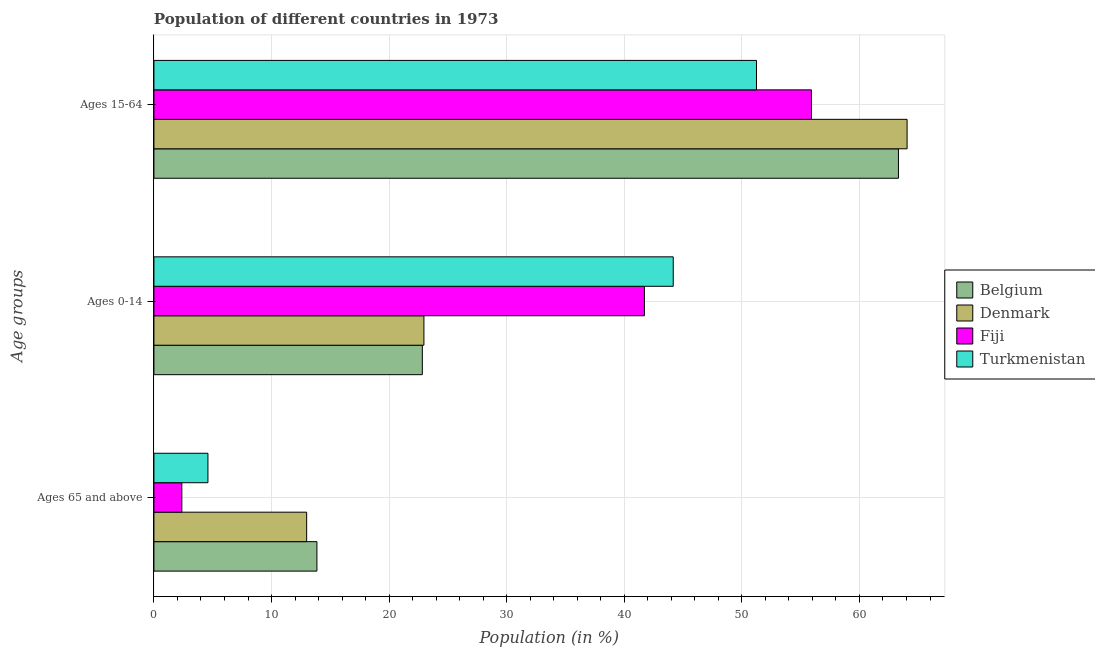How many bars are there on the 3rd tick from the top?
Offer a terse response. 4. How many bars are there on the 2nd tick from the bottom?
Offer a very short reply. 4. What is the label of the 3rd group of bars from the top?
Make the answer very short. Ages 65 and above. What is the percentage of population within the age-group of 65 and above in Fiji?
Your response must be concise. 2.37. Across all countries, what is the maximum percentage of population within the age-group of 65 and above?
Your answer should be very brief. 13.86. Across all countries, what is the minimum percentage of population within the age-group 0-14?
Ensure brevity in your answer.  22.82. In which country was the percentage of population within the age-group 0-14 maximum?
Provide a succinct answer. Turkmenistan. What is the total percentage of population within the age-group 15-64 in the graph?
Your answer should be compact. 234.52. What is the difference between the percentage of population within the age-group of 65 and above in Turkmenistan and that in Fiji?
Your answer should be compact. 2.22. What is the difference between the percentage of population within the age-group of 65 and above in Turkmenistan and the percentage of population within the age-group 0-14 in Denmark?
Provide a succinct answer. -18.37. What is the average percentage of population within the age-group 0-14 per country?
Offer a terse response. 32.91. What is the difference between the percentage of population within the age-group 0-14 and percentage of population within the age-group 15-64 in Belgium?
Offer a very short reply. -40.49. In how many countries, is the percentage of population within the age-group of 65 and above greater than 12 %?
Your answer should be very brief. 2. What is the ratio of the percentage of population within the age-group 0-14 in Denmark to that in Turkmenistan?
Keep it short and to the point. 0.52. Is the percentage of population within the age-group 15-64 in Turkmenistan less than that in Fiji?
Your response must be concise. Yes. Is the difference between the percentage of population within the age-group 0-14 in Turkmenistan and Fiji greater than the difference between the percentage of population within the age-group of 65 and above in Turkmenistan and Fiji?
Provide a short and direct response. Yes. What is the difference between the highest and the second highest percentage of population within the age-group 0-14?
Ensure brevity in your answer.  2.45. What is the difference between the highest and the lowest percentage of population within the age-group 15-64?
Offer a terse response. 12.81. In how many countries, is the percentage of population within the age-group of 65 and above greater than the average percentage of population within the age-group of 65 and above taken over all countries?
Ensure brevity in your answer.  2. What does the 1st bar from the top in Ages 0-14 represents?
Keep it short and to the point. Turkmenistan. What does the 4th bar from the bottom in Ages 65 and above represents?
Your response must be concise. Turkmenistan. Is it the case that in every country, the sum of the percentage of population within the age-group of 65 and above and percentage of population within the age-group 0-14 is greater than the percentage of population within the age-group 15-64?
Give a very brief answer. No. Are all the bars in the graph horizontal?
Keep it short and to the point. Yes. How many countries are there in the graph?
Your answer should be very brief. 4. Are the values on the major ticks of X-axis written in scientific E-notation?
Give a very brief answer. No. How many legend labels are there?
Ensure brevity in your answer.  4. How are the legend labels stacked?
Offer a terse response. Vertical. What is the title of the graph?
Make the answer very short. Population of different countries in 1973. What is the label or title of the X-axis?
Offer a terse response. Population (in %). What is the label or title of the Y-axis?
Give a very brief answer. Age groups. What is the Population (in %) of Belgium in Ages 65 and above?
Offer a terse response. 13.86. What is the Population (in %) in Denmark in Ages 65 and above?
Your answer should be very brief. 12.99. What is the Population (in %) of Fiji in Ages 65 and above?
Offer a terse response. 2.37. What is the Population (in %) of Turkmenistan in Ages 65 and above?
Provide a succinct answer. 4.59. What is the Population (in %) in Belgium in Ages 0-14?
Offer a very short reply. 22.82. What is the Population (in %) in Denmark in Ages 0-14?
Provide a succinct answer. 22.96. What is the Population (in %) in Fiji in Ages 0-14?
Offer a very short reply. 41.71. What is the Population (in %) in Turkmenistan in Ages 0-14?
Provide a short and direct response. 44.16. What is the Population (in %) in Belgium in Ages 15-64?
Your response must be concise. 63.31. What is the Population (in %) in Denmark in Ages 15-64?
Provide a succinct answer. 64.05. What is the Population (in %) in Fiji in Ages 15-64?
Your answer should be very brief. 55.92. What is the Population (in %) in Turkmenistan in Ages 15-64?
Offer a very short reply. 51.24. Across all Age groups, what is the maximum Population (in %) of Belgium?
Offer a very short reply. 63.31. Across all Age groups, what is the maximum Population (in %) in Denmark?
Make the answer very short. 64.05. Across all Age groups, what is the maximum Population (in %) of Fiji?
Your answer should be very brief. 55.92. Across all Age groups, what is the maximum Population (in %) in Turkmenistan?
Keep it short and to the point. 51.24. Across all Age groups, what is the minimum Population (in %) in Belgium?
Offer a terse response. 13.86. Across all Age groups, what is the minimum Population (in %) in Denmark?
Provide a succinct answer. 12.99. Across all Age groups, what is the minimum Population (in %) of Fiji?
Your answer should be very brief. 2.37. Across all Age groups, what is the minimum Population (in %) of Turkmenistan?
Your answer should be very brief. 4.59. What is the total Population (in %) of Turkmenistan in the graph?
Provide a short and direct response. 100. What is the difference between the Population (in %) of Belgium in Ages 65 and above and that in Ages 0-14?
Offer a terse response. -8.96. What is the difference between the Population (in %) of Denmark in Ages 65 and above and that in Ages 0-14?
Provide a succinct answer. -9.97. What is the difference between the Population (in %) in Fiji in Ages 65 and above and that in Ages 0-14?
Provide a short and direct response. -39.34. What is the difference between the Population (in %) of Turkmenistan in Ages 65 and above and that in Ages 0-14?
Keep it short and to the point. -39.57. What is the difference between the Population (in %) of Belgium in Ages 65 and above and that in Ages 15-64?
Provide a succinct answer. -49.45. What is the difference between the Population (in %) of Denmark in Ages 65 and above and that in Ages 15-64?
Ensure brevity in your answer.  -51.06. What is the difference between the Population (in %) in Fiji in Ages 65 and above and that in Ages 15-64?
Provide a succinct answer. -53.54. What is the difference between the Population (in %) of Turkmenistan in Ages 65 and above and that in Ages 15-64?
Make the answer very short. -46.65. What is the difference between the Population (in %) of Belgium in Ages 0-14 and that in Ages 15-64?
Provide a short and direct response. -40.49. What is the difference between the Population (in %) of Denmark in Ages 0-14 and that in Ages 15-64?
Keep it short and to the point. -41.09. What is the difference between the Population (in %) of Fiji in Ages 0-14 and that in Ages 15-64?
Provide a short and direct response. -14.2. What is the difference between the Population (in %) in Turkmenistan in Ages 0-14 and that in Ages 15-64?
Ensure brevity in your answer.  -7.08. What is the difference between the Population (in %) of Belgium in Ages 65 and above and the Population (in %) of Denmark in Ages 0-14?
Your answer should be compact. -9.1. What is the difference between the Population (in %) in Belgium in Ages 65 and above and the Population (in %) in Fiji in Ages 0-14?
Offer a terse response. -27.85. What is the difference between the Population (in %) of Belgium in Ages 65 and above and the Population (in %) of Turkmenistan in Ages 0-14?
Give a very brief answer. -30.3. What is the difference between the Population (in %) in Denmark in Ages 65 and above and the Population (in %) in Fiji in Ages 0-14?
Ensure brevity in your answer.  -28.72. What is the difference between the Population (in %) of Denmark in Ages 65 and above and the Population (in %) of Turkmenistan in Ages 0-14?
Keep it short and to the point. -31.17. What is the difference between the Population (in %) of Fiji in Ages 65 and above and the Population (in %) of Turkmenistan in Ages 0-14?
Your answer should be very brief. -41.79. What is the difference between the Population (in %) in Belgium in Ages 65 and above and the Population (in %) in Denmark in Ages 15-64?
Your answer should be very brief. -50.19. What is the difference between the Population (in %) of Belgium in Ages 65 and above and the Population (in %) of Fiji in Ages 15-64?
Ensure brevity in your answer.  -42.05. What is the difference between the Population (in %) in Belgium in Ages 65 and above and the Population (in %) in Turkmenistan in Ages 15-64?
Ensure brevity in your answer.  -37.38. What is the difference between the Population (in %) of Denmark in Ages 65 and above and the Population (in %) of Fiji in Ages 15-64?
Offer a very short reply. -42.93. What is the difference between the Population (in %) in Denmark in Ages 65 and above and the Population (in %) in Turkmenistan in Ages 15-64?
Ensure brevity in your answer.  -38.26. What is the difference between the Population (in %) in Fiji in Ages 65 and above and the Population (in %) in Turkmenistan in Ages 15-64?
Give a very brief answer. -48.87. What is the difference between the Population (in %) in Belgium in Ages 0-14 and the Population (in %) in Denmark in Ages 15-64?
Give a very brief answer. -41.23. What is the difference between the Population (in %) of Belgium in Ages 0-14 and the Population (in %) of Fiji in Ages 15-64?
Keep it short and to the point. -33.09. What is the difference between the Population (in %) of Belgium in Ages 0-14 and the Population (in %) of Turkmenistan in Ages 15-64?
Offer a very short reply. -28.42. What is the difference between the Population (in %) in Denmark in Ages 0-14 and the Population (in %) in Fiji in Ages 15-64?
Your answer should be very brief. -32.95. What is the difference between the Population (in %) of Denmark in Ages 0-14 and the Population (in %) of Turkmenistan in Ages 15-64?
Offer a terse response. -28.28. What is the difference between the Population (in %) in Fiji in Ages 0-14 and the Population (in %) in Turkmenistan in Ages 15-64?
Provide a short and direct response. -9.53. What is the average Population (in %) in Belgium per Age groups?
Offer a very short reply. 33.33. What is the average Population (in %) in Denmark per Age groups?
Provide a short and direct response. 33.33. What is the average Population (in %) of Fiji per Age groups?
Ensure brevity in your answer.  33.33. What is the average Population (in %) of Turkmenistan per Age groups?
Ensure brevity in your answer.  33.33. What is the difference between the Population (in %) in Belgium and Population (in %) in Denmark in Ages 65 and above?
Make the answer very short. 0.87. What is the difference between the Population (in %) in Belgium and Population (in %) in Fiji in Ages 65 and above?
Give a very brief answer. 11.49. What is the difference between the Population (in %) of Belgium and Population (in %) of Turkmenistan in Ages 65 and above?
Your response must be concise. 9.27. What is the difference between the Population (in %) of Denmark and Population (in %) of Fiji in Ages 65 and above?
Your answer should be compact. 10.62. What is the difference between the Population (in %) of Denmark and Population (in %) of Turkmenistan in Ages 65 and above?
Keep it short and to the point. 8.39. What is the difference between the Population (in %) in Fiji and Population (in %) in Turkmenistan in Ages 65 and above?
Ensure brevity in your answer.  -2.22. What is the difference between the Population (in %) in Belgium and Population (in %) in Denmark in Ages 0-14?
Make the answer very short. -0.14. What is the difference between the Population (in %) of Belgium and Population (in %) of Fiji in Ages 0-14?
Provide a succinct answer. -18.89. What is the difference between the Population (in %) of Belgium and Population (in %) of Turkmenistan in Ages 0-14?
Your answer should be compact. -21.34. What is the difference between the Population (in %) in Denmark and Population (in %) in Fiji in Ages 0-14?
Ensure brevity in your answer.  -18.75. What is the difference between the Population (in %) of Denmark and Population (in %) of Turkmenistan in Ages 0-14?
Make the answer very short. -21.2. What is the difference between the Population (in %) of Fiji and Population (in %) of Turkmenistan in Ages 0-14?
Your answer should be compact. -2.45. What is the difference between the Population (in %) of Belgium and Population (in %) of Denmark in Ages 15-64?
Your response must be concise. -0.74. What is the difference between the Population (in %) of Belgium and Population (in %) of Fiji in Ages 15-64?
Make the answer very short. 7.4. What is the difference between the Population (in %) in Belgium and Population (in %) in Turkmenistan in Ages 15-64?
Keep it short and to the point. 12.07. What is the difference between the Population (in %) in Denmark and Population (in %) in Fiji in Ages 15-64?
Give a very brief answer. 8.13. What is the difference between the Population (in %) in Denmark and Population (in %) in Turkmenistan in Ages 15-64?
Provide a succinct answer. 12.81. What is the difference between the Population (in %) in Fiji and Population (in %) in Turkmenistan in Ages 15-64?
Give a very brief answer. 4.67. What is the ratio of the Population (in %) of Belgium in Ages 65 and above to that in Ages 0-14?
Your answer should be compact. 0.61. What is the ratio of the Population (in %) of Denmark in Ages 65 and above to that in Ages 0-14?
Offer a very short reply. 0.57. What is the ratio of the Population (in %) in Fiji in Ages 65 and above to that in Ages 0-14?
Ensure brevity in your answer.  0.06. What is the ratio of the Population (in %) in Turkmenistan in Ages 65 and above to that in Ages 0-14?
Make the answer very short. 0.1. What is the ratio of the Population (in %) in Belgium in Ages 65 and above to that in Ages 15-64?
Your answer should be compact. 0.22. What is the ratio of the Population (in %) of Denmark in Ages 65 and above to that in Ages 15-64?
Your response must be concise. 0.2. What is the ratio of the Population (in %) in Fiji in Ages 65 and above to that in Ages 15-64?
Offer a terse response. 0.04. What is the ratio of the Population (in %) in Turkmenistan in Ages 65 and above to that in Ages 15-64?
Provide a short and direct response. 0.09. What is the ratio of the Population (in %) in Belgium in Ages 0-14 to that in Ages 15-64?
Provide a short and direct response. 0.36. What is the ratio of the Population (in %) of Denmark in Ages 0-14 to that in Ages 15-64?
Make the answer very short. 0.36. What is the ratio of the Population (in %) in Fiji in Ages 0-14 to that in Ages 15-64?
Offer a very short reply. 0.75. What is the ratio of the Population (in %) in Turkmenistan in Ages 0-14 to that in Ages 15-64?
Your answer should be very brief. 0.86. What is the difference between the highest and the second highest Population (in %) of Belgium?
Your answer should be very brief. 40.49. What is the difference between the highest and the second highest Population (in %) of Denmark?
Keep it short and to the point. 41.09. What is the difference between the highest and the second highest Population (in %) of Fiji?
Keep it short and to the point. 14.2. What is the difference between the highest and the second highest Population (in %) in Turkmenistan?
Ensure brevity in your answer.  7.08. What is the difference between the highest and the lowest Population (in %) in Belgium?
Make the answer very short. 49.45. What is the difference between the highest and the lowest Population (in %) in Denmark?
Offer a very short reply. 51.06. What is the difference between the highest and the lowest Population (in %) in Fiji?
Ensure brevity in your answer.  53.54. What is the difference between the highest and the lowest Population (in %) in Turkmenistan?
Make the answer very short. 46.65. 